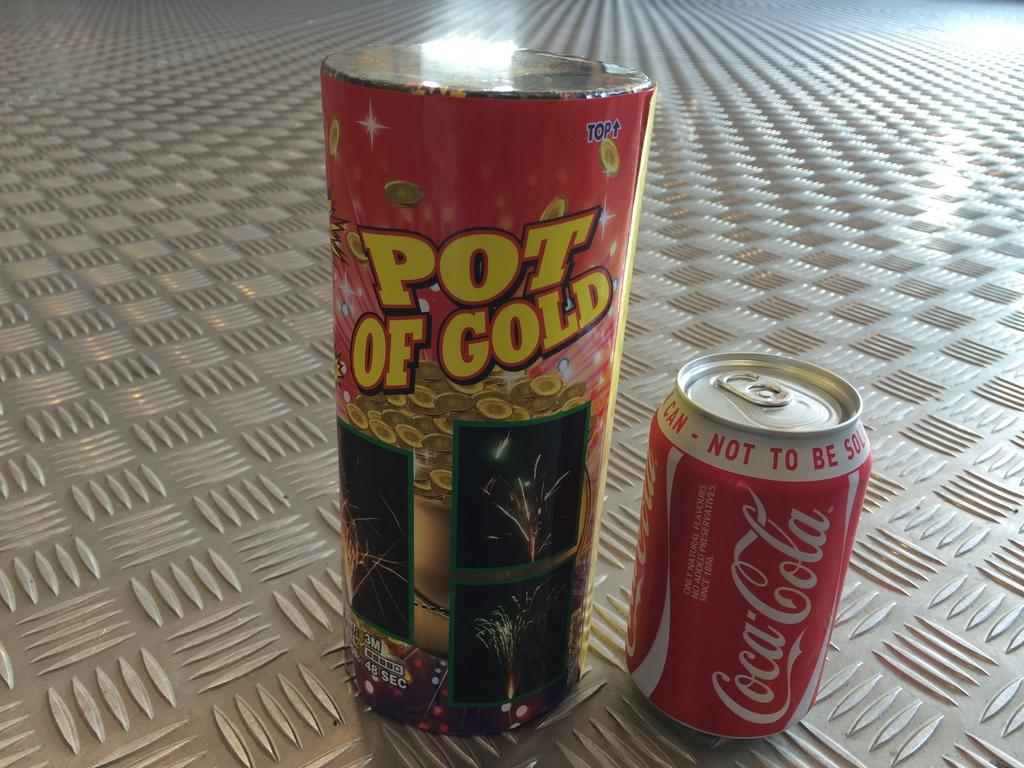<image>
Share a concise interpretation of the image provided. A can of coca cola is next to pot of gold. 